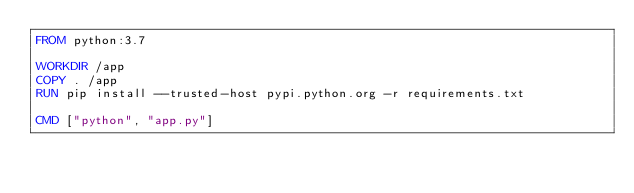<code> <loc_0><loc_0><loc_500><loc_500><_Dockerfile_>FROM python:3.7

WORKDIR /app
COPY . /app
RUN pip install --trusted-host pypi.python.org -r requirements.txt

CMD ["python", "app.py"]</code> 